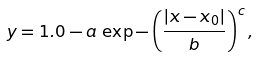Convert formula to latex. <formula><loc_0><loc_0><loc_500><loc_500>y = 1 . 0 - a \, \exp - \left ( \frac { | x - x _ { 0 } | } { b } \right ) ^ { c } ,</formula> 